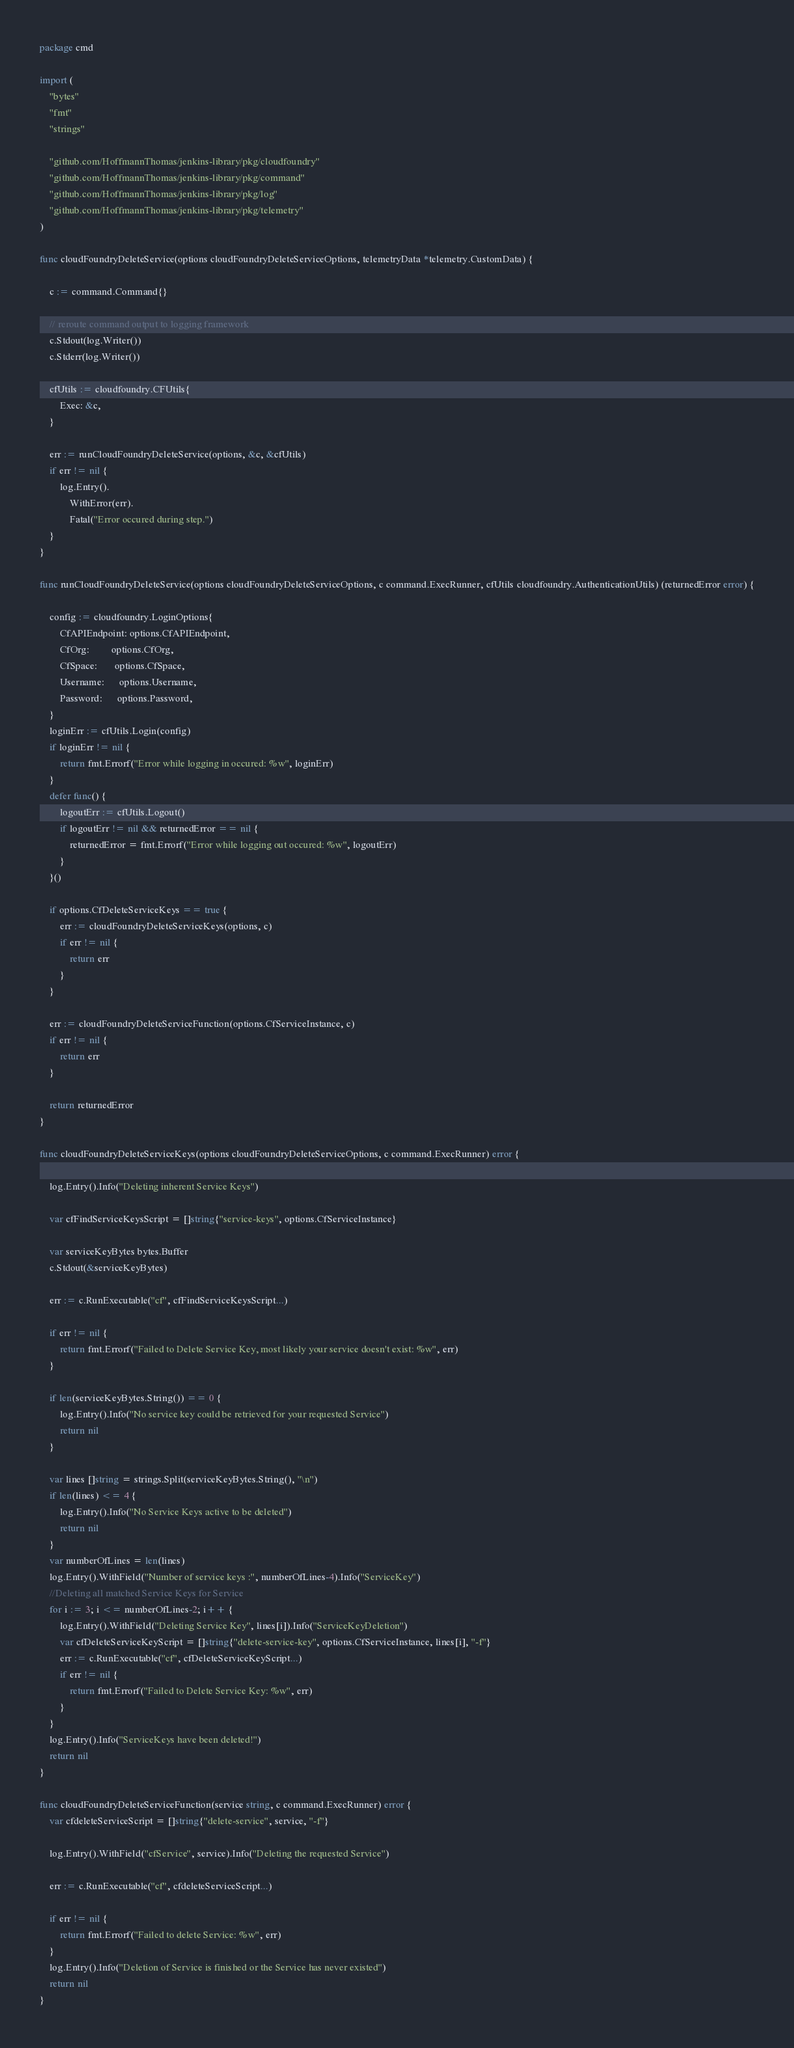Convert code to text. <code><loc_0><loc_0><loc_500><loc_500><_Go_>package cmd

import (
	"bytes"
	"fmt"
	"strings"

	"github.com/HoffmannThomas/jenkins-library/pkg/cloudfoundry"
	"github.com/HoffmannThomas/jenkins-library/pkg/command"
	"github.com/HoffmannThomas/jenkins-library/pkg/log"
	"github.com/HoffmannThomas/jenkins-library/pkg/telemetry"
)

func cloudFoundryDeleteService(options cloudFoundryDeleteServiceOptions, telemetryData *telemetry.CustomData) {

	c := command.Command{}

	// reroute command output to logging framework
	c.Stdout(log.Writer())
	c.Stderr(log.Writer())

	cfUtils := cloudfoundry.CFUtils{
		Exec: &c,
	}

	err := runCloudFoundryDeleteService(options, &c, &cfUtils)
	if err != nil {
		log.Entry().
			WithError(err).
			Fatal("Error occured during step.")
	}
}

func runCloudFoundryDeleteService(options cloudFoundryDeleteServiceOptions, c command.ExecRunner, cfUtils cloudfoundry.AuthenticationUtils) (returnedError error) {

	config := cloudfoundry.LoginOptions{
		CfAPIEndpoint: options.CfAPIEndpoint,
		CfOrg:         options.CfOrg,
		CfSpace:       options.CfSpace,
		Username:      options.Username,
		Password:      options.Password,
	}
	loginErr := cfUtils.Login(config)
	if loginErr != nil {
		return fmt.Errorf("Error while logging in occured: %w", loginErr)
	}
	defer func() {
		logoutErr := cfUtils.Logout()
		if logoutErr != nil && returnedError == nil {
			returnedError = fmt.Errorf("Error while logging out occured: %w", logoutErr)
		}
	}()

	if options.CfDeleteServiceKeys == true {
		err := cloudFoundryDeleteServiceKeys(options, c)
		if err != nil {
			return err
		}
	}

	err := cloudFoundryDeleteServiceFunction(options.CfServiceInstance, c)
	if err != nil {
		return err
	}

	return returnedError
}

func cloudFoundryDeleteServiceKeys(options cloudFoundryDeleteServiceOptions, c command.ExecRunner) error {

	log.Entry().Info("Deleting inherent Service Keys")

	var cfFindServiceKeysScript = []string{"service-keys", options.CfServiceInstance}

	var serviceKeyBytes bytes.Buffer
	c.Stdout(&serviceKeyBytes)

	err := c.RunExecutable("cf", cfFindServiceKeysScript...)

	if err != nil {
		return fmt.Errorf("Failed to Delete Service Key, most likely your service doesn't exist: %w", err)
	}

	if len(serviceKeyBytes.String()) == 0 {
		log.Entry().Info("No service key could be retrieved for your requested Service")
		return nil
	}

	var lines []string = strings.Split(serviceKeyBytes.String(), "\n")
	if len(lines) <= 4 {
		log.Entry().Info("No Service Keys active to be deleted")
		return nil
	}
	var numberOfLines = len(lines)
	log.Entry().WithField("Number of service keys :", numberOfLines-4).Info("ServiceKey")
	//Deleting all matched Service Keys for Service
	for i := 3; i <= numberOfLines-2; i++ {
		log.Entry().WithField("Deleting Service Key", lines[i]).Info("ServiceKeyDeletion")
		var cfDeleteServiceKeyScript = []string{"delete-service-key", options.CfServiceInstance, lines[i], "-f"}
		err := c.RunExecutable("cf", cfDeleteServiceKeyScript...)
		if err != nil {
			return fmt.Errorf("Failed to Delete Service Key: %w", err)
		}
	}
	log.Entry().Info("ServiceKeys have been deleted!")
	return nil
}

func cloudFoundryDeleteServiceFunction(service string, c command.ExecRunner) error {
	var cfdeleteServiceScript = []string{"delete-service", service, "-f"}

	log.Entry().WithField("cfService", service).Info("Deleting the requested Service")

	err := c.RunExecutable("cf", cfdeleteServiceScript...)

	if err != nil {
		return fmt.Errorf("Failed to delete Service: %w", err)
	}
	log.Entry().Info("Deletion of Service is finished or the Service has never existed")
	return nil
}
</code> 